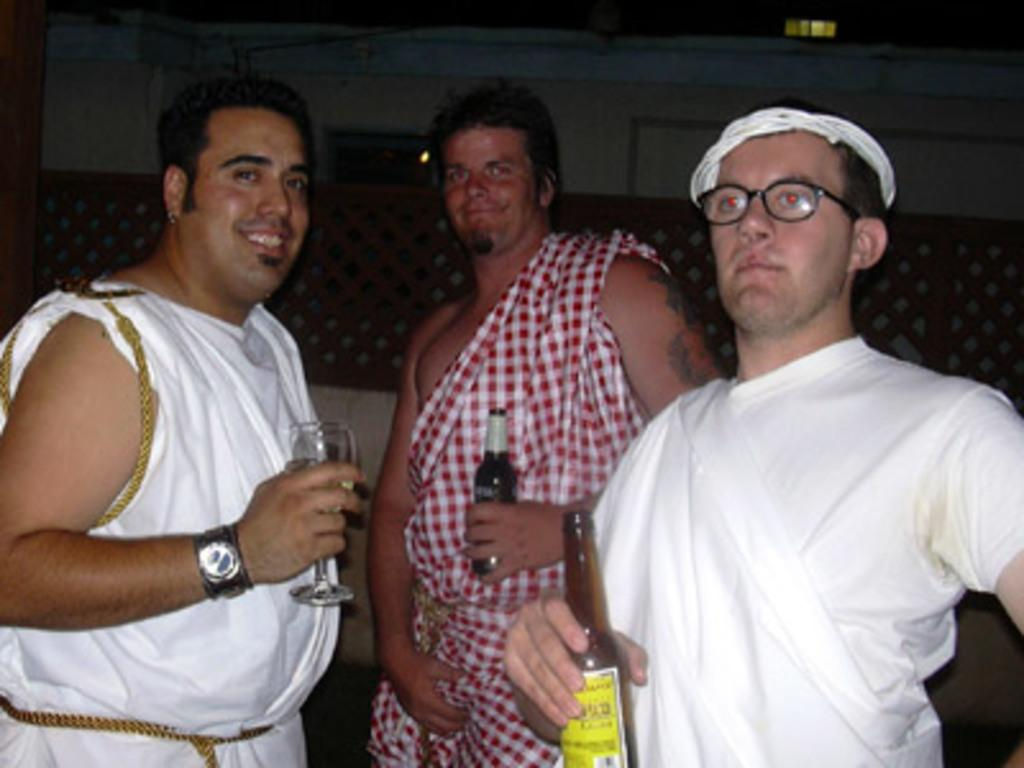How many men are present in the image? There are three men standing in the image. What is one of the men holding? One of the men is holding a wine glass. What are the other two men holding? The other two men are holding glass bottles. What type of hair can be seen on the playground in the image? There is no playground or hair visible in the image. 